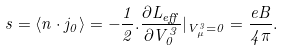Convert formula to latex. <formula><loc_0><loc_0><loc_500><loc_500>s = \langle n \cdot j _ { 0 } \rangle = - \frac { 1 } { 2 } . \frac { \partial L _ { e f f } } { \partial V _ { 0 } ^ { 3 } } | _ { V _ { \mu } ^ { 3 } = 0 } = \frac { e B } { 4 \pi } .</formula> 